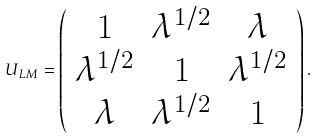Convert formula to latex. <formula><loc_0><loc_0><loc_500><loc_500>U _ { L M } = \left ( \begin{array} { c c c } 1 & \lambda ^ { 1 / 2 } & \lambda \\ \lambda ^ { 1 / 2 } & 1 & \lambda ^ { 1 / 2 } \\ \lambda & \lambda ^ { 1 / 2 } & 1 \end{array} \right ) .</formula> 